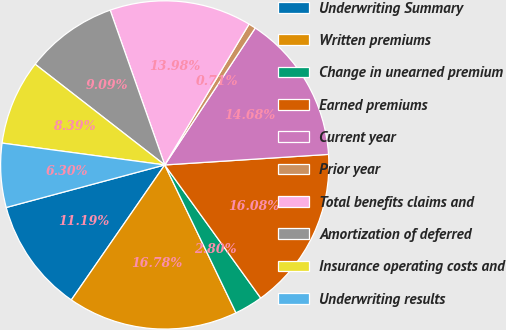Convert chart. <chart><loc_0><loc_0><loc_500><loc_500><pie_chart><fcel>Underwriting Summary<fcel>Written premiums<fcel>Change in unearned premium<fcel>Earned premiums<fcel>Current year<fcel>Prior year<fcel>Total benefits claims and<fcel>Amortization of deferred<fcel>Insurance operating costs and<fcel>Underwriting results<nl><fcel>11.19%<fcel>16.78%<fcel>2.8%<fcel>16.08%<fcel>14.68%<fcel>0.71%<fcel>13.98%<fcel>9.09%<fcel>8.39%<fcel>6.3%<nl></chart> 